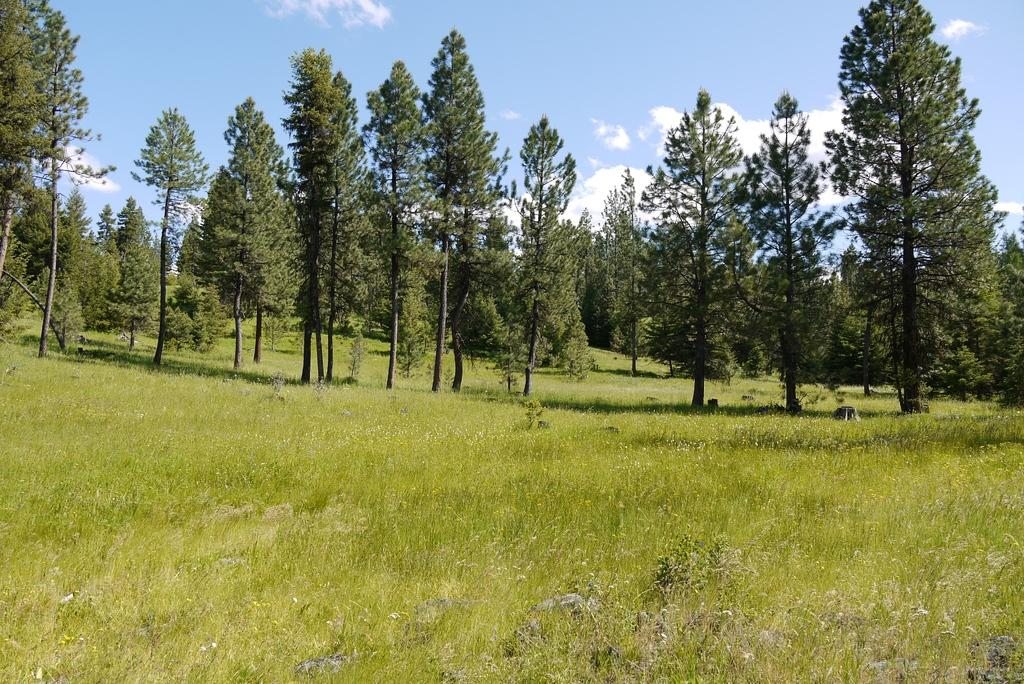What type of vegetation can be seen in the image? There are trees and grass in the image. What other objects can be found on the ground in the image? There are stones in the image. What is visible in the background of the image? The sky is visible in the background of the image. What can be seen in the sky? Clouds are present in the sky. Where is the gun hidden in the image? There is no gun present in the image. What type of bell can be heard ringing in the image? There is no bell present in the image, and therefore no sound can be heard. 